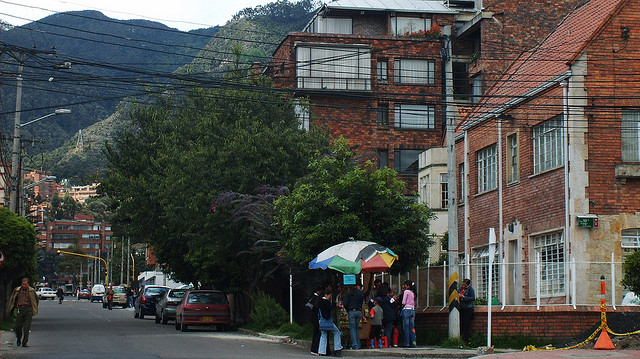How many grey bears are in the picture? 0 